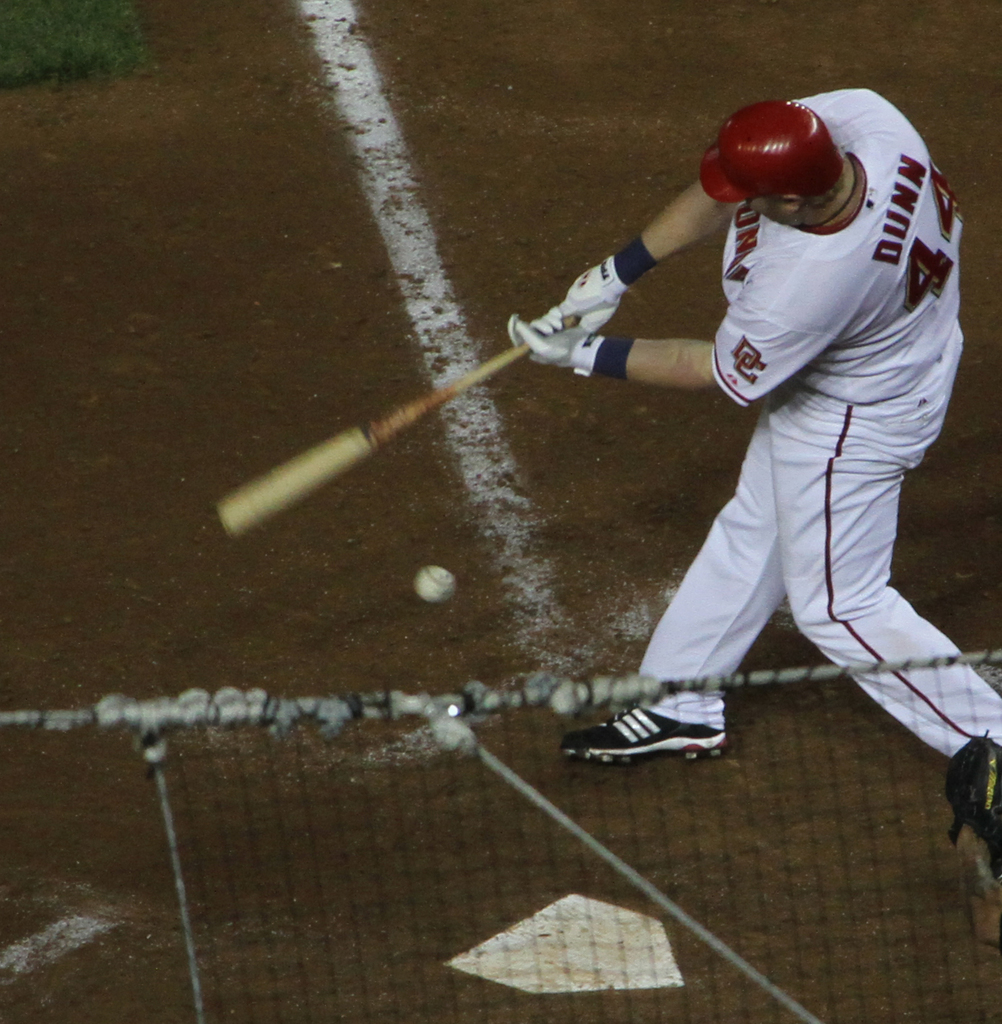What details can you observe about the player's equipment? The player is equipped with a white helmet, batting gloves, and cleats, all of which match his team's colors. His bat appears to be wooden, typical of professional league standards. 